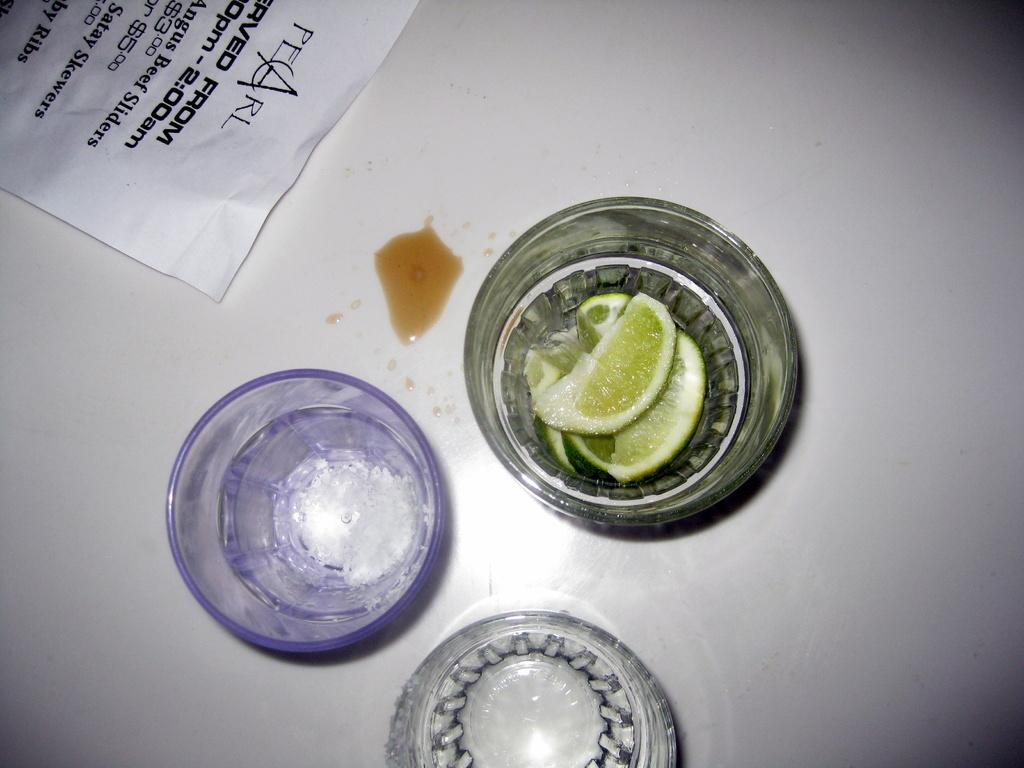What type of fruit is present in the image? There are lime pieces in the image. What is contained in the glass in the image? There is salt in a glass in the image. Can you see a hand holding the lime pieces in the image? There is no hand holding the lime pieces in the image. Is there a ghost visible in the image? There is no ghost present in the image. 